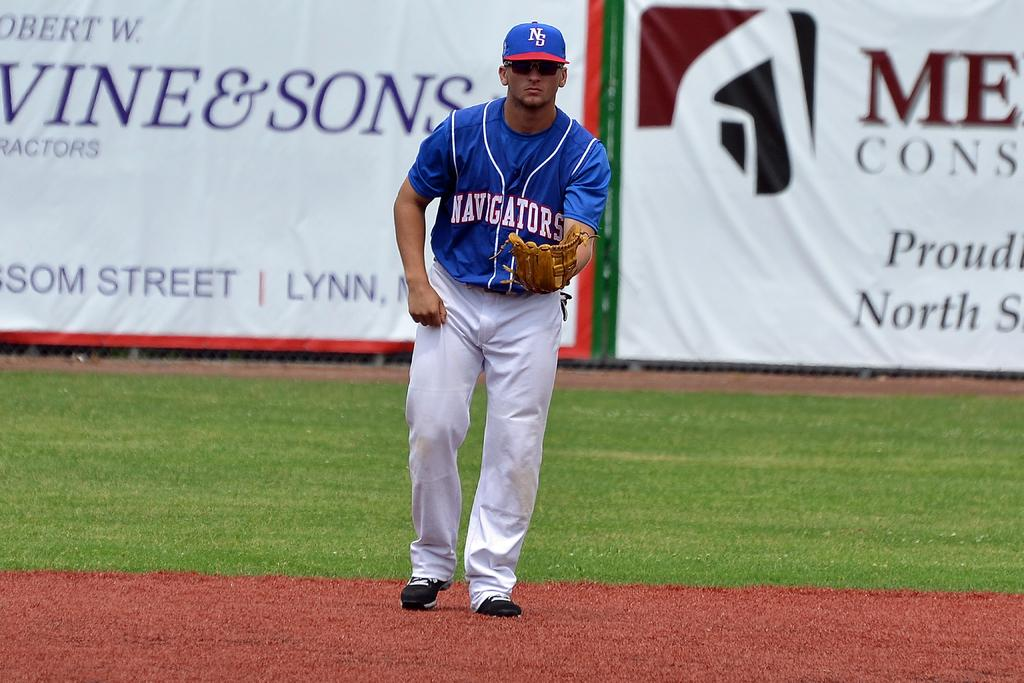<image>
Summarize the visual content of the image. the name vin and sons on an ad in the outfield 